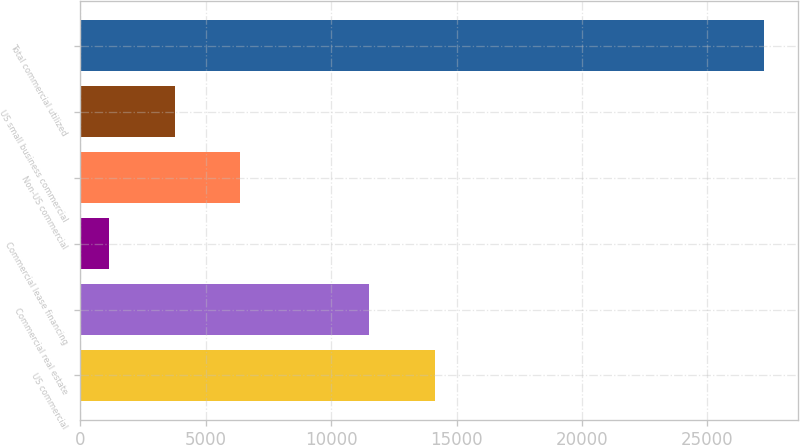Convert chart to OTSL. <chart><loc_0><loc_0><loc_500><loc_500><bar_chart><fcel>US commercial<fcel>Commercial real estate<fcel>Commercial lease financing<fcel>Non-US commercial<fcel>US small business commercial<fcel>Total commercial utilized<nl><fcel>14135.7<fcel>11525<fcel>1140<fcel>6361.4<fcel>3750.7<fcel>27247<nl></chart> 